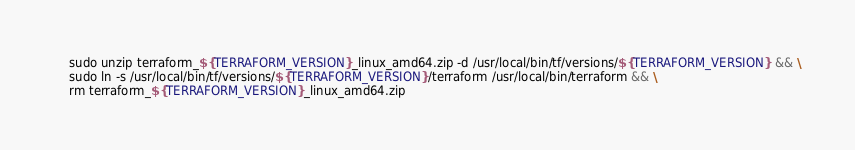Convert code to text. <code><loc_0><loc_0><loc_500><loc_500><_Dockerfile_>    sudo unzip terraform_${TERRAFORM_VERSION}_linux_amd64.zip -d /usr/local/bin/tf/versions/${TERRAFORM_VERSION} && \
    sudo ln -s /usr/local/bin/tf/versions/${TERRAFORM_VERSION}/terraform /usr/local/bin/terraform && \
    rm terraform_${TERRAFORM_VERSION}_linux_amd64.zip
</code> 